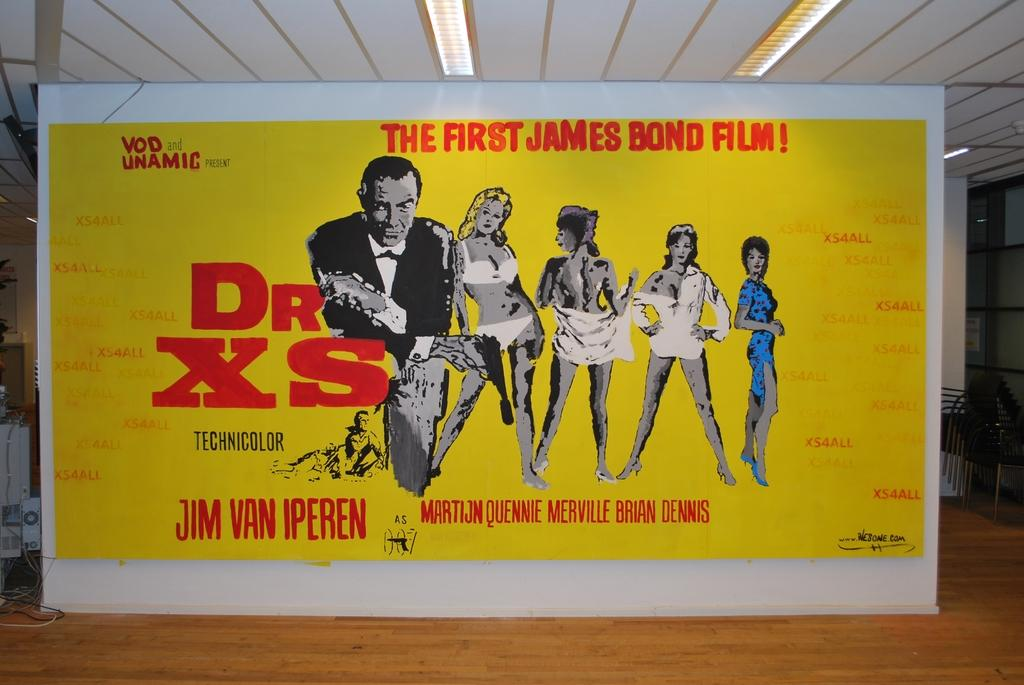<image>
Relay a brief, clear account of the picture shown. A poster for a film called Dr XS the first james bond film 